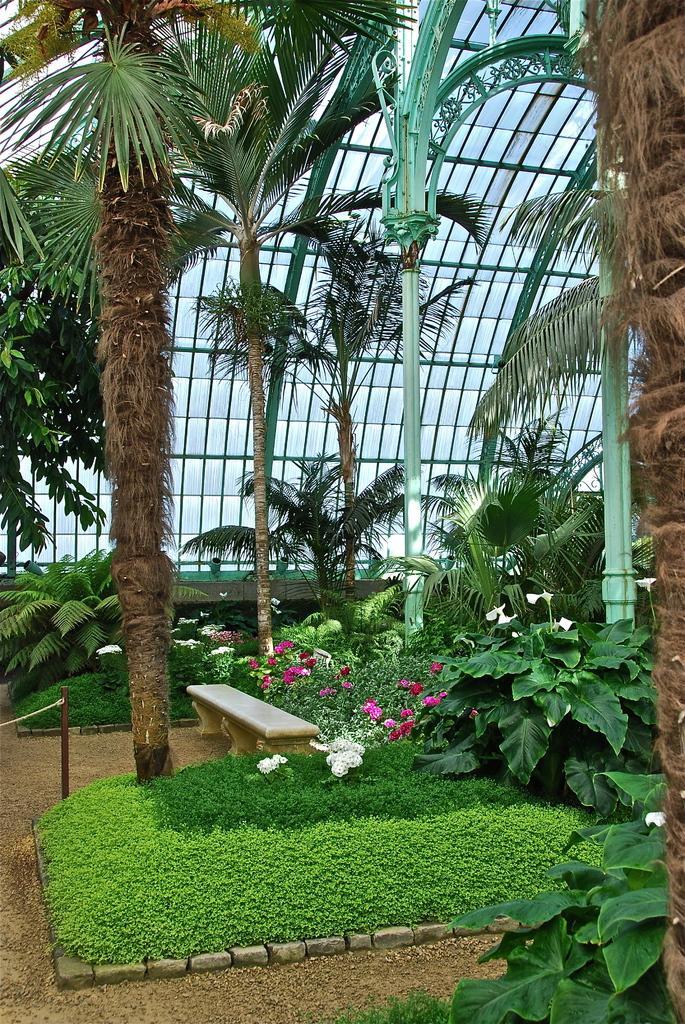In one or two sentences, can you explain what this image depicts? In this image we can see trees, plants with flowers, plants are on the ground under a glass roof and we can see the poles. 